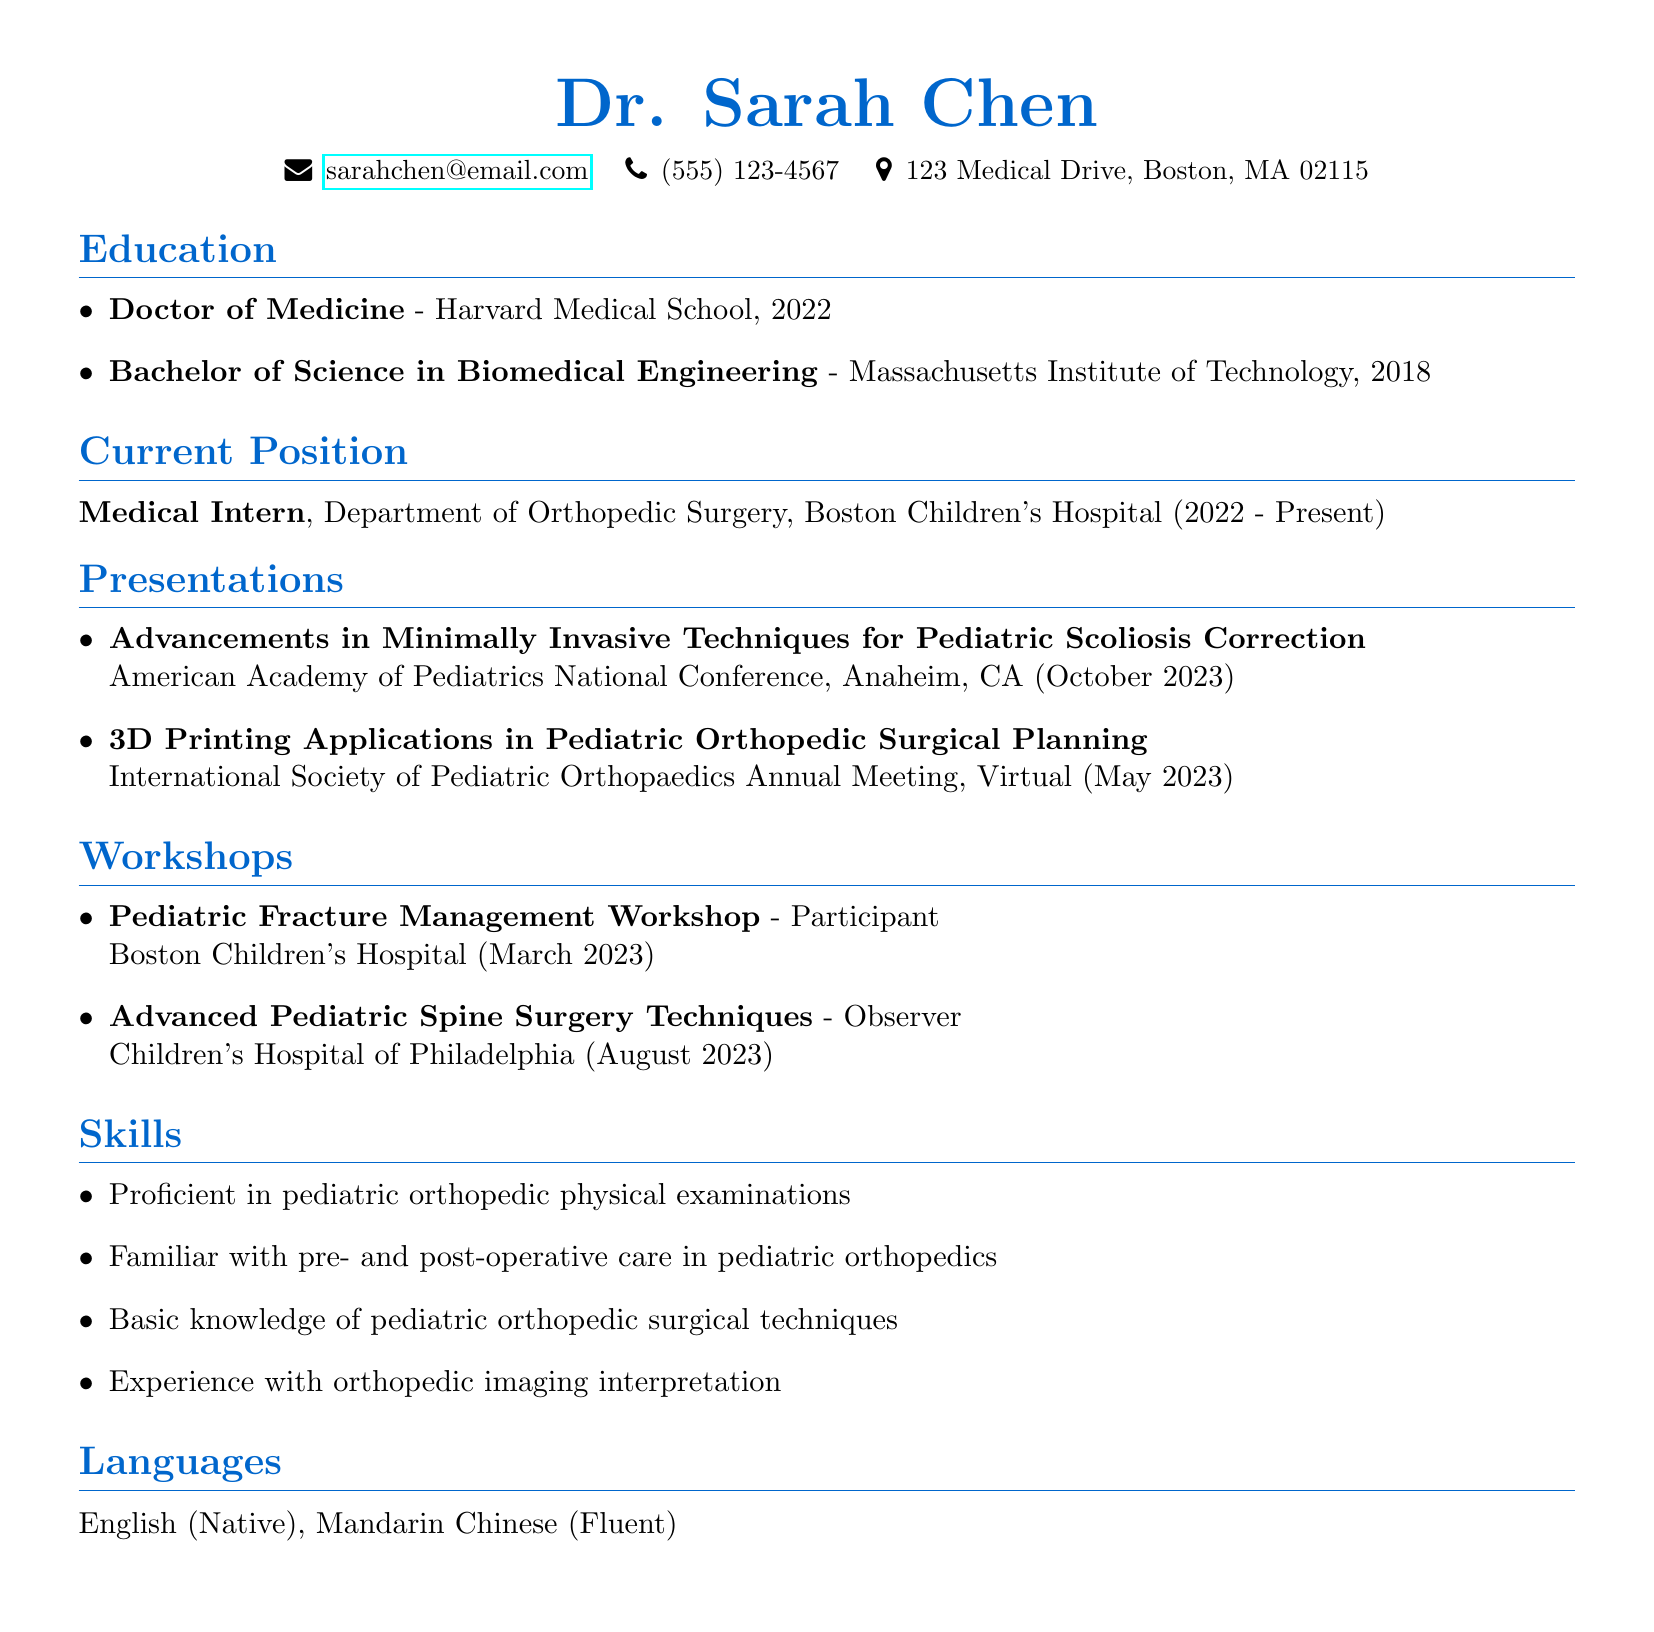What is the name of the medical intern? The name of the medical intern is stated in the personal information section of the document.
Answer: Dr. Sarah Chen What is the location of the American Academy of Pediatrics National Conference? The location of the conference is provided in the presentations section of the document.
Answer: Anaheim, CA What is the date of the 3D Printing Applications presentation? This date can be found under the presentations section of the document.
Answer: May 2023 Which workshop did Dr. Sarah Chen participate in at Boston Children's Hospital? The workshops section lists Dr. Chen's participation, specifically the title of one workshop.
Answer: Pediatric Fracture Management Workshop How many years did Dr. Sarah Chen attend medical school? The duration can be estimated by looking at the education timeline, specifically from the year of her undergraduate completion to her medical school graduation.
Answer: 4 years What type of degree did Dr. Sarah Chen earn from Harvard Medical School? The document specifies the degree obtained, which is part of the education section.
Answer: Doctor of Medicine Where did Dr. Sarah Chen conduct the "Advanced Pediatric Spine Surgery Techniques" workshop observation? This information can be found in the workshops section of the document.
Answer: Children's Hospital of Philadelphia What is the primary focus of Dr. Sarah Chen's current position? The current position describes the department relevant to her intern role, indicating the area of focus.
Answer: Orthopedic Surgery 